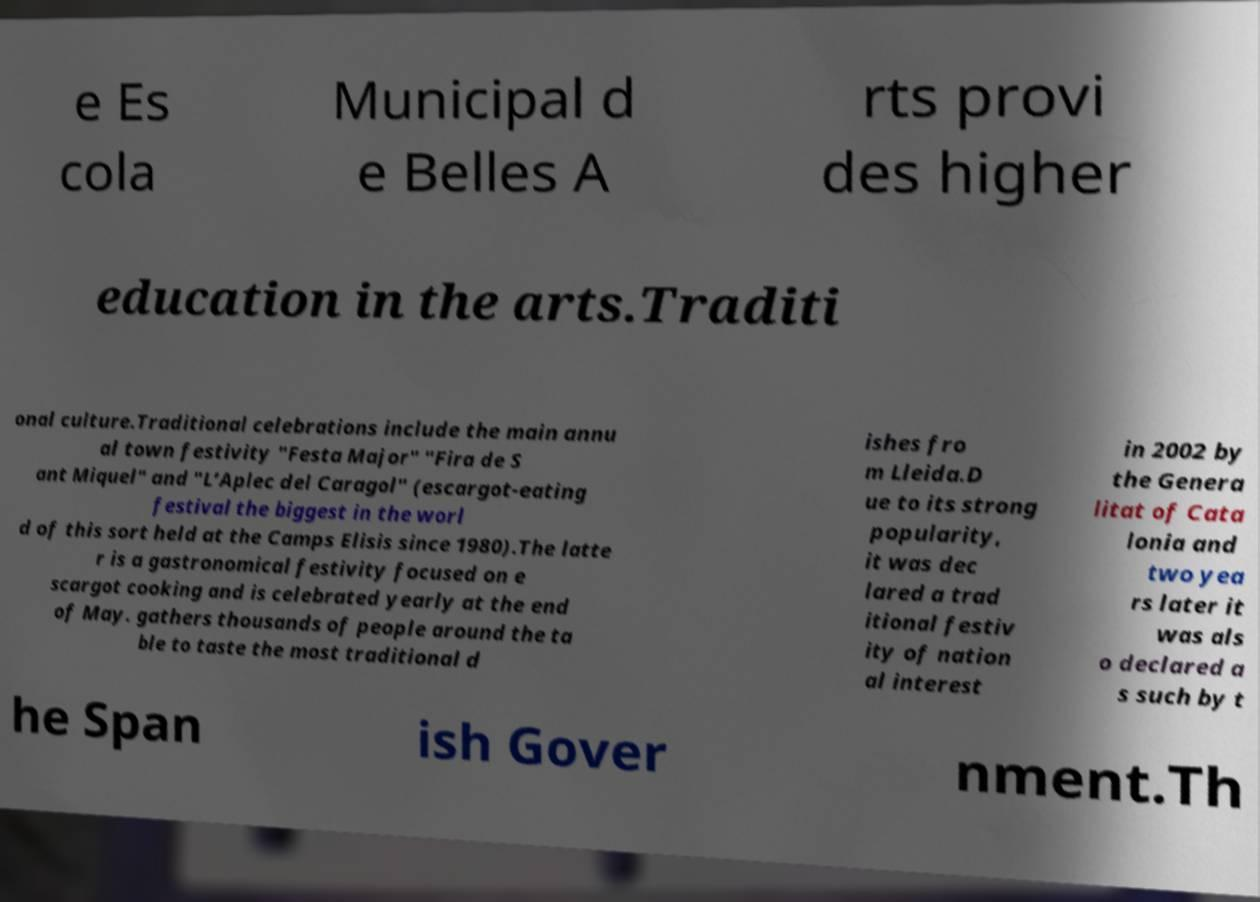Can you read and provide the text displayed in the image?This photo seems to have some interesting text. Can you extract and type it out for me? e Es cola Municipal d e Belles A rts provi des higher education in the arts.Traditi onal culture.Traditional celebrations include the main annu al town festivity "Festa Major" "Fira de S ant Miquel" and "L’Aplec del Caragol" (escargot-eating festival the biggest in the worl d of this sort held at the Camps Elisis since 1980).The latte r is a gastronomical festivity focused on e scargot cooking and is celebrated yearly at the end of May. gathers thousands of people around the ta ble to taste the most traditional d ishes fro m Lleida.D ue to its strong popularity, it was dec lared a trad itional festiv ity of nation al interest in 2002 by the Genera litat of Cata lonia and two yea rs later it was als o declared a s such by t he Span ish Gover nment.Th 